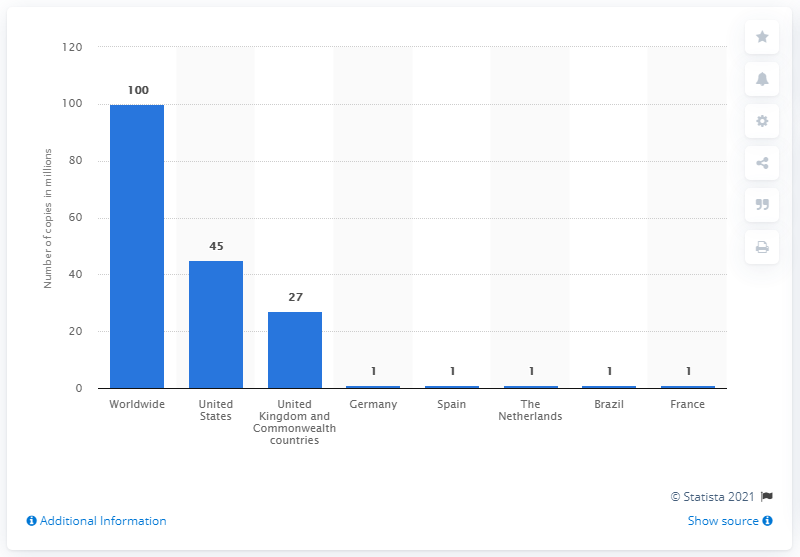Draw attention to some important aspects in this diagram. As of February 2014, it was reported that 100 million copies of "50 Shades of Grey" had been sold worldwide. 